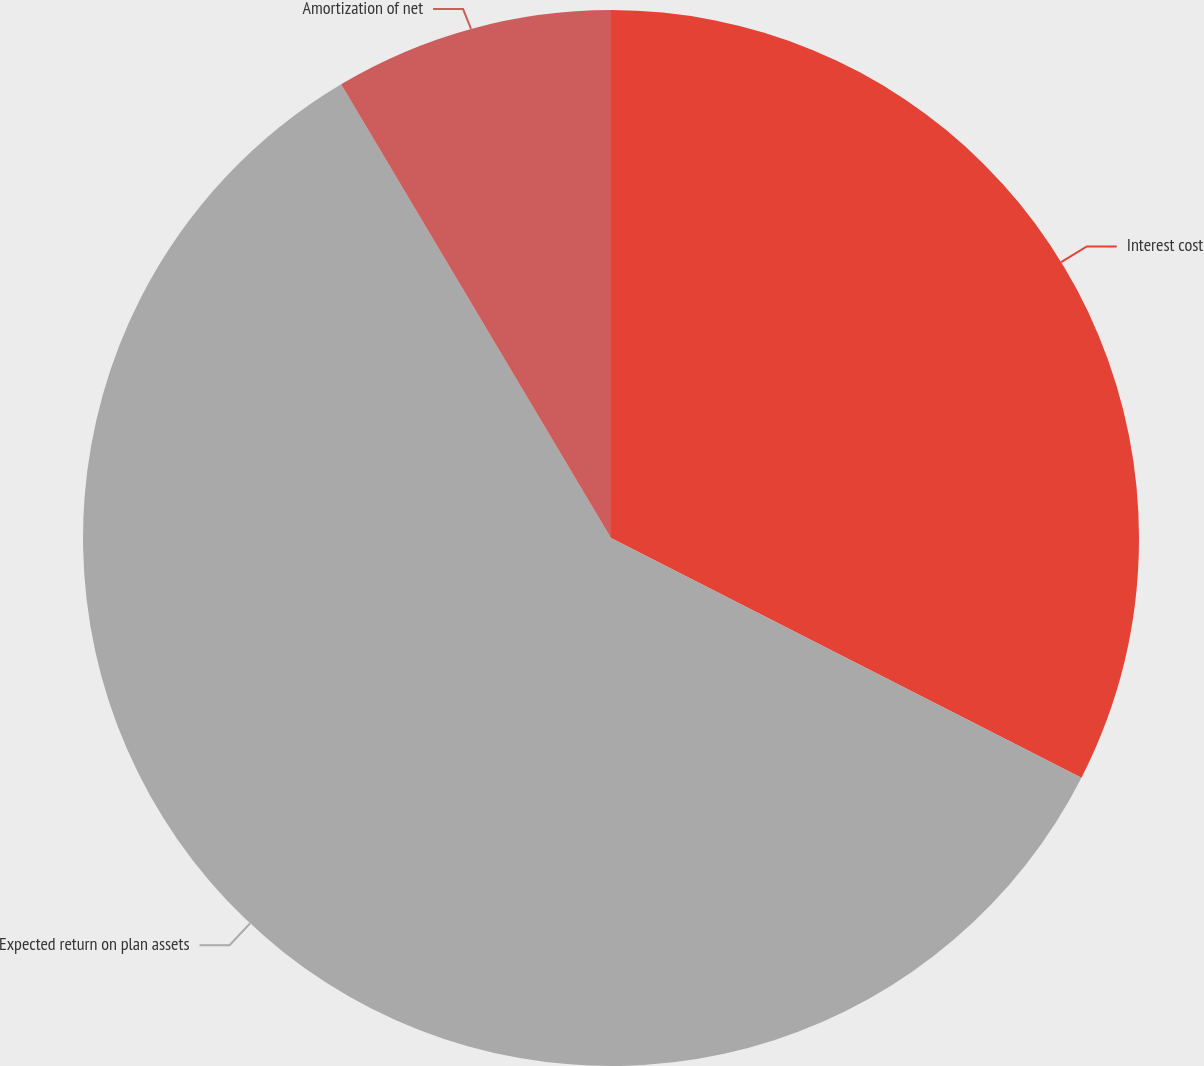<chart> <loc_0><loc_0><loc_500><loc_500><pie_chart><fcel>Interest cost<fcel>Expected return on plan assets<fcel>Amortization of net<nl><fcel>32.5%<fcel>58.96%<fcel>8.54%<nl></chart> 